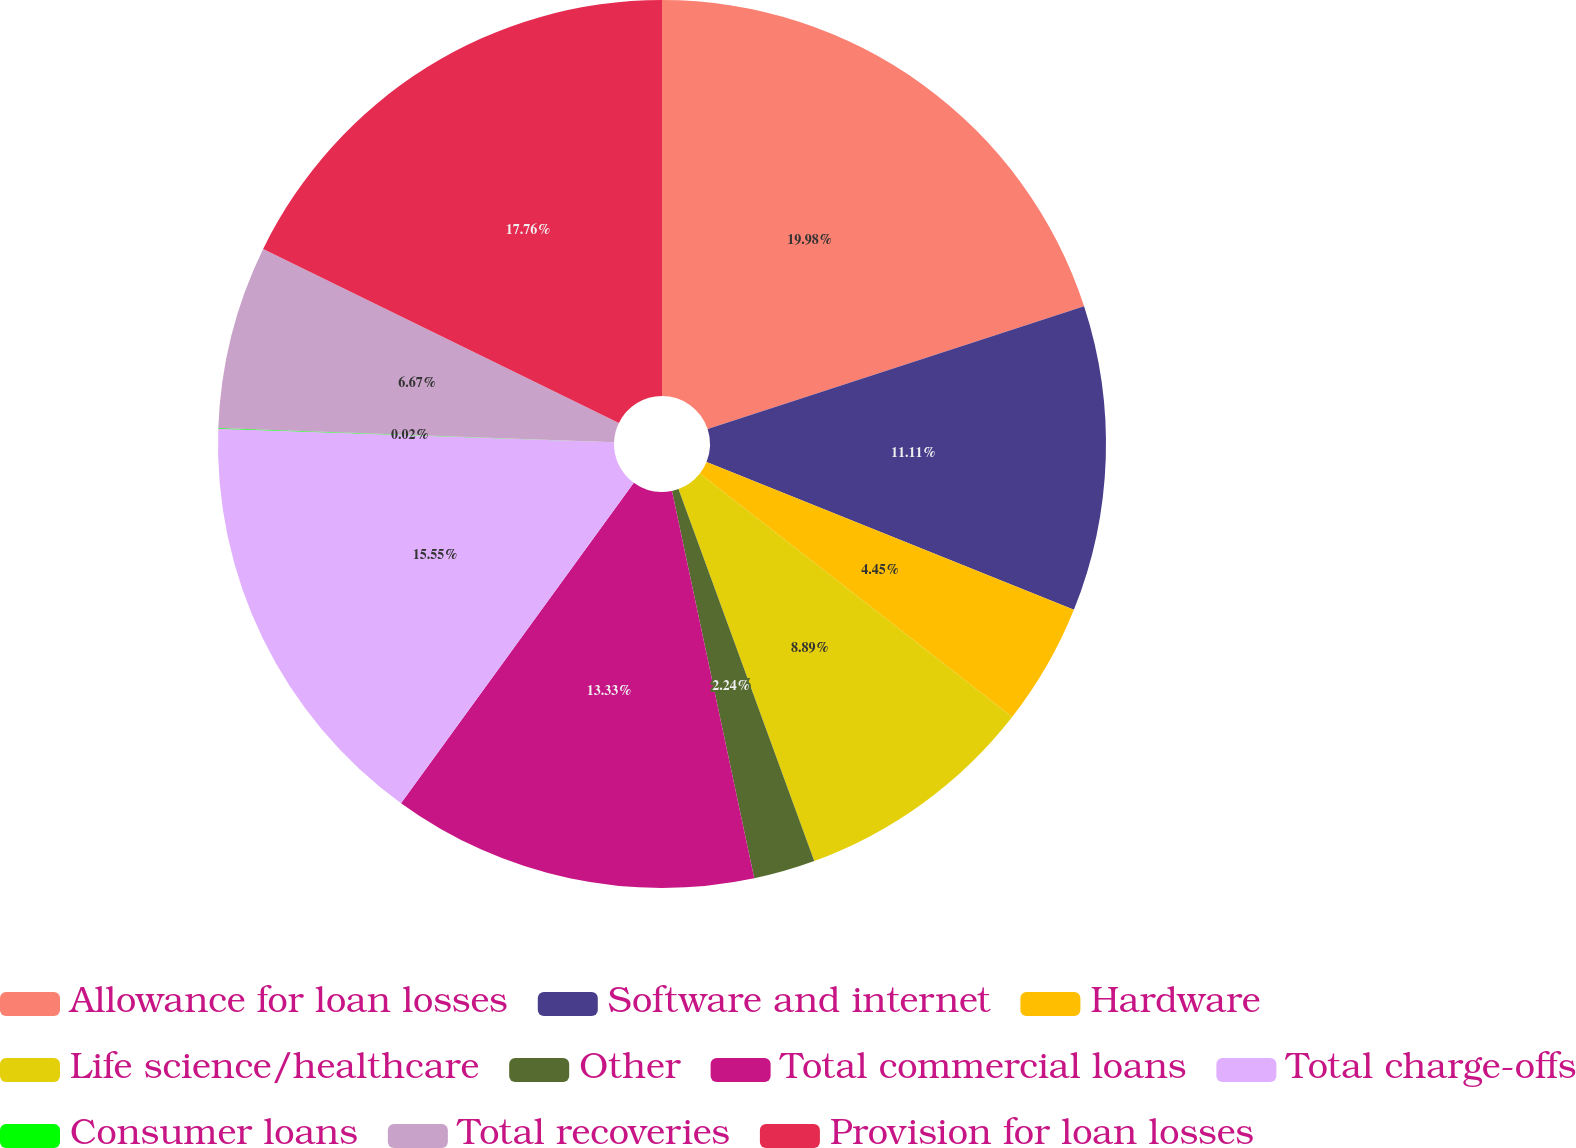<chart> <loc_0><loc_0><loc_500><loc_500><pie_chart><fcel>Allowance for loan losses<fcel>Software and internet<fcel>Hardware<fcel>Life science/healthcare<fcel>Other<fcel>Total commercial loans<fcel>Total charge-offs<fcel>Consumer loans<fcel>Total recoveries<fcel>Provision for loan losses<nl><fcel>19.98%<fcel>11.11%<fcel>4.45%<fcel>8.89%<fcel>2.24%<fcel>13.33%<fcel>15.55%<fcel>0.02%<fcel>6.67%<fcel>17.76%<nl></chart> 